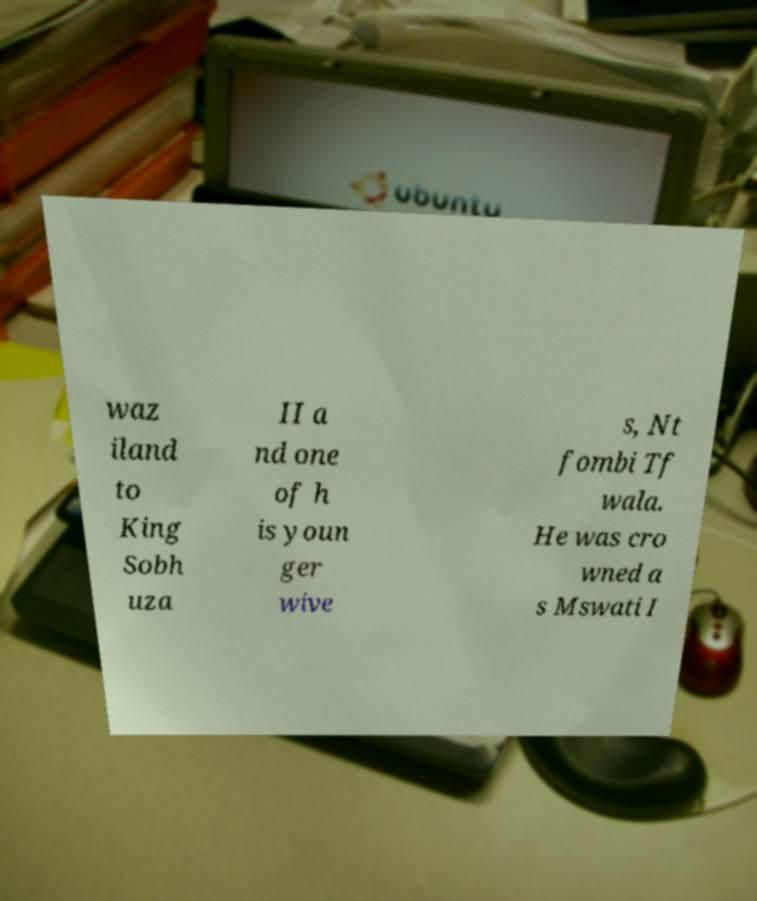Could you assist in decoding the text presented in this image and type it out clearly? waz iland to King Sobh uza II a nd one of h is youn ger wive s, Nt fombi Tf wala. He was cro wned a s Mswati I 